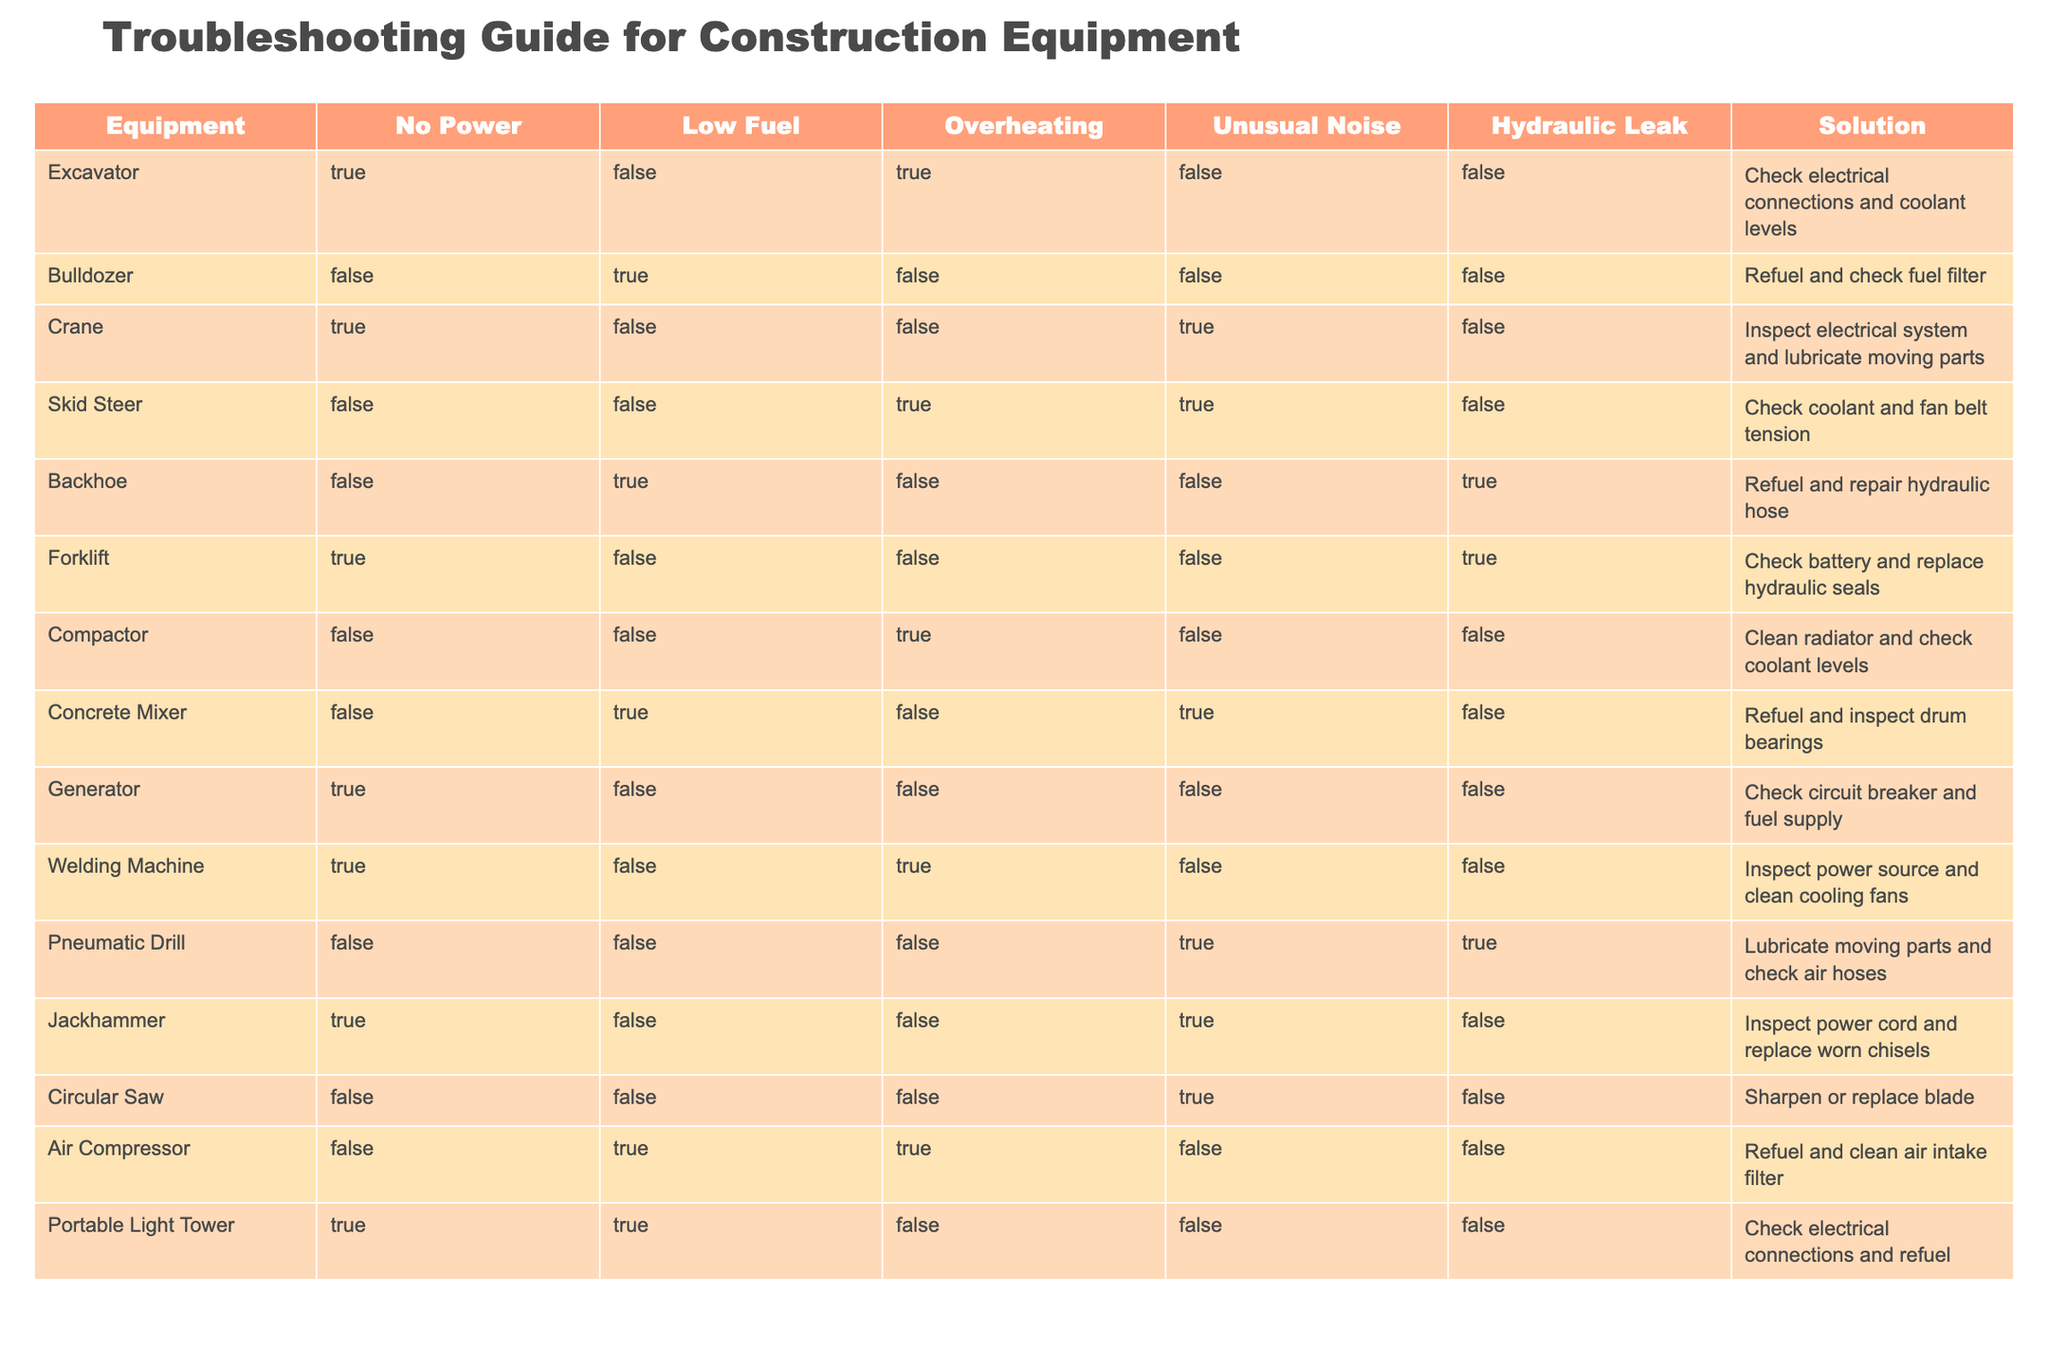What common solution can be applied to an Excavator experiencing overheating? The table shows that for an Excavator, if it is experiencing overheating, the suggested solution is to check electrical connections and coolant levels.
Answer: Check electrical connections and coolant levels Which equipment has issues with hydraulic leaks, and what is the solution? From the table, the Backhoe is the only equipment listed with a hydraulic leak issue. The suggested solution is to refuel and repair the hydraulic hose.
Answer: Backhoe; Refuel and repair hydraulic hose How many pieces of equipment show symptoms of no power? By examining the table, I can see that there are three equipment types showing symptoms of no power: Excavator, Crane, and Forklift. Therefore, the total count is three.
Answer: 3 Is it true that the Skid Steer is experiencing unusual noise? According to the table, the Skid Steer does show symptoms of unusual noise (TRUE). Therefore, the answer is yes.
Answer: Yes What is the most common solution across all listed equipment? Analyzing the solutions provided in the table reveals that the phrase “check” appears multiple times in the suggestions. Specifically, checking electrical connections, refueling, and checking coolant levels are common across different pieces of machinery. Thus, the most frequent action indicated is "check".
Answer: Check connections and levels Which equipment requires refueling and has an issue with low fuel? The table indicates that two pieces of equipment require refueling due to low fuel: Bulldozer and Concrete Mixer. The Bulldozer's solution is to refuel and check the fuel filter, while the Concrete Mixer's solution is to refuel and inspect drum bearings.
Answer: Bulldozer and Concrete Mixer If a Crane is making unusual noise, what should be done? According to the table, if a Crane is producing unusual noise, the solution is to inspect the electrical system and lubricate moving parts. This information can be directly derived from the row pertaining to the Crane.
Answer: Inspect electrical system and lubricate moving parts What is the total number of equipment displaying symptoms of overheating? Referring to the table, there are four pieces of equipment showing symptoms of overheating: Excavator, Skid Steer, Compactor, and Welding Machine. Hence, the total is four.
Answer: 4 Which equipment has a unique issue regarding hydraulic leaks and what is the proposed remedy? The only equipment with a specific issue regarding hydraulic leaks is the Forklift. The proposed remedy, as noted in the table, is to check the battery and replace hydraulic seals.
Answer: Forklift; Check battery and replace hydraulic seals 